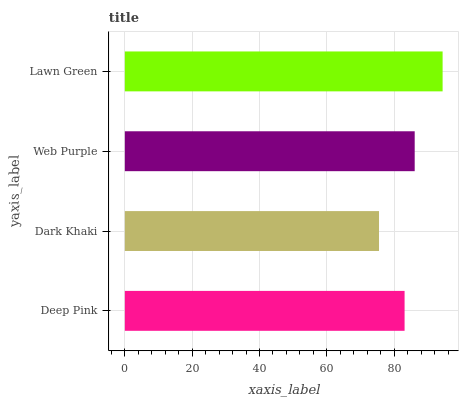Is Dark Khaki the minimum?
Answer yes or no. Yes. Is Lawn Green the maximum?
Answer yes or no. Yes. Is Web Purple the minimum?
Answer yes or no. No. Is Web Purple the maximum?
Answer yes or no. No. Is Web Purple greater than Dark Khaki?
Answer yes or no. Yes. Is Dark Khaki less than Web Purple?
Answer yes or no. Yes. Is Dark Khaki greater than Web Purple?
Answer yes or no. No. Is Web Purple less than Dark Khaki?
Answer yes or no. No. Is Web Purple the high median?
Answer yes or no. Yes. Is Deep Pink the low median?
Answer yes or no. Yes. Is Deep Pink the high median?
Answer yes or no. No. Is Lawn Green the low median?
Answer yes or no. No. 